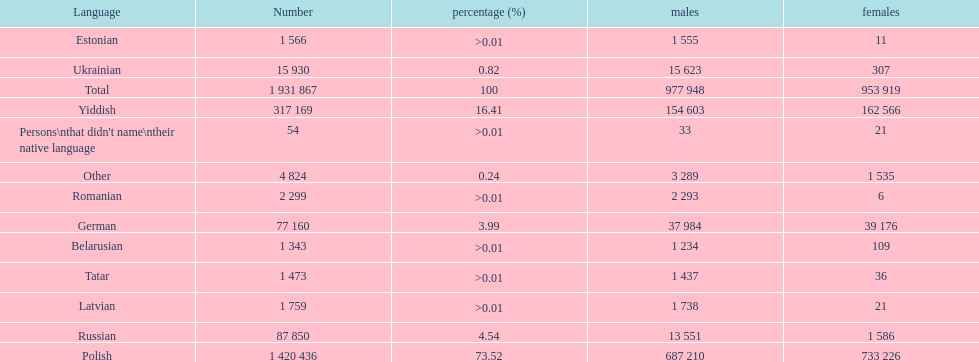What is the highest percentage of speakers other than polish? Yiddish. 